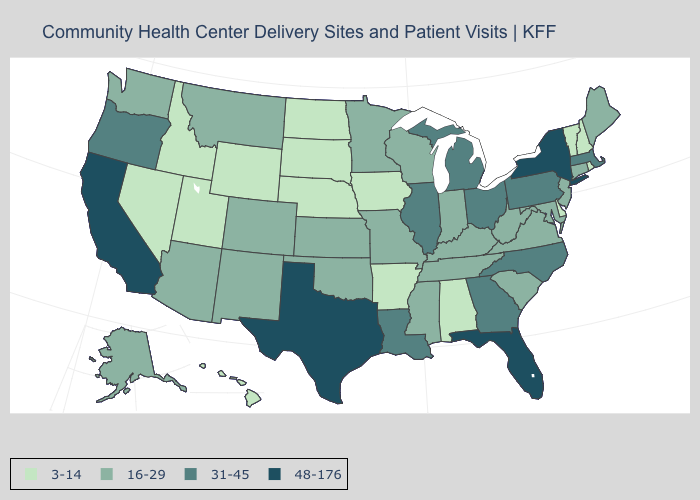What is the value of Maine?
Concise answer only. 16-29. Which states have the highest value in the USA?
Quick response, please. California, Florida, New York, Texas. Does the first symbol in the legend represent the smallest category?
Keep it brief. Yes. Among the states that border Wyoming , does Colorado have the highest value?
Concise answer only. Yes. What is the highest value in states that border Massachusetts?
Quick response, please. 48-176. Which states have the lowest value in the South?
Keep it brief. Alabama, Arkansas, Delaware. What is the value of California?
Short answer required. 48-176. What is the lowest value in states that border Nevada?
Be succinct. 3-14. Which states have the lowest value in the USA?
Concise answer only. Alabama, Arkansas, Delaware, Hawaii, Idaho, Iowa, Nebraska, Nevada, New Hampshire, North Dakota, Rhode Island, South Dakota, Utah, Vermont, Wyoming. Does Georgia have a higher value than Alabama?
Answer briefly. Yes. Does Hawaii have the highest value in the USA?
Short answer required. No. Name the states that have a value in the range 48-176?
Concise answer only. California, Florida, New York, Texas. Name the states that have a value in the range 16-29?
Be succinct. Alaska, Arizona, Colorado, Connecticut, Indiana, Kansas, Kentucky, Maine, Maryland, Minnesota, Mississippi, Missouri, Montana, New Jersey, New Mexico, Oklahoma, South Carolina, Tennessee, Virginia, Washington, West Virginia, Wisconsin. What is the highest value in the USA?
Give a very brief answer. 48-176. Does New Mexico have the highest value in the West?
Be succinct. No. 